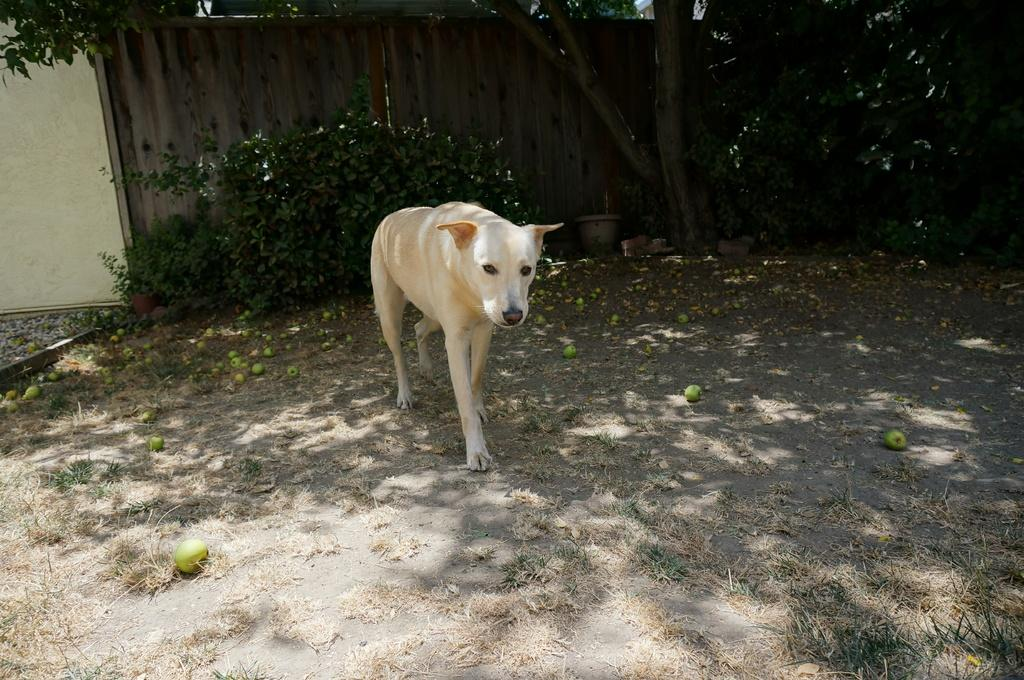What type of animal is in the image? There is a dog in the image. What is on the ground near the dog? There are fruits on the ground in the image. What can be seen in the distance behind the dog? There is a wall and trees in the background of the image. Can you describe any other objects in the background? There are some unspecified objects in the background of the image. How many legs does the hair expert have in the image? There is no hair expert or mention of hair in the image; it features a dog and other objects. 